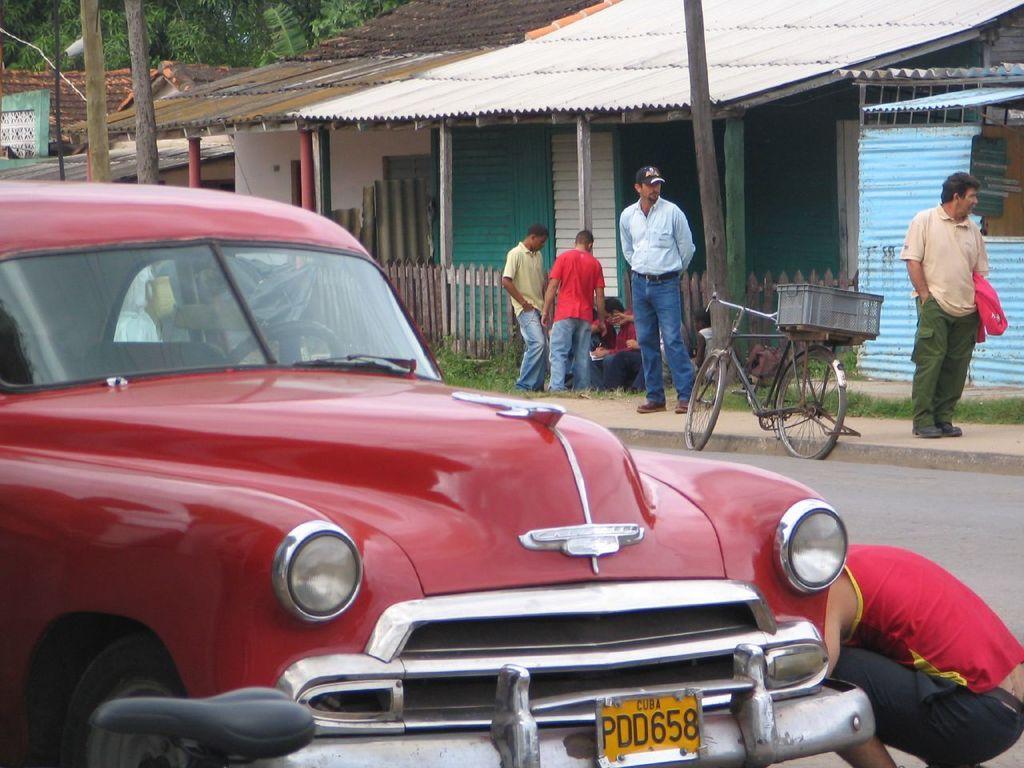Could you give a brief overview of what you see in this image? In the foreground of the image there is a red color car. In the background of the image there are houses. There are people. There is a bicycle on the road. To the right side of the image there is a person. 